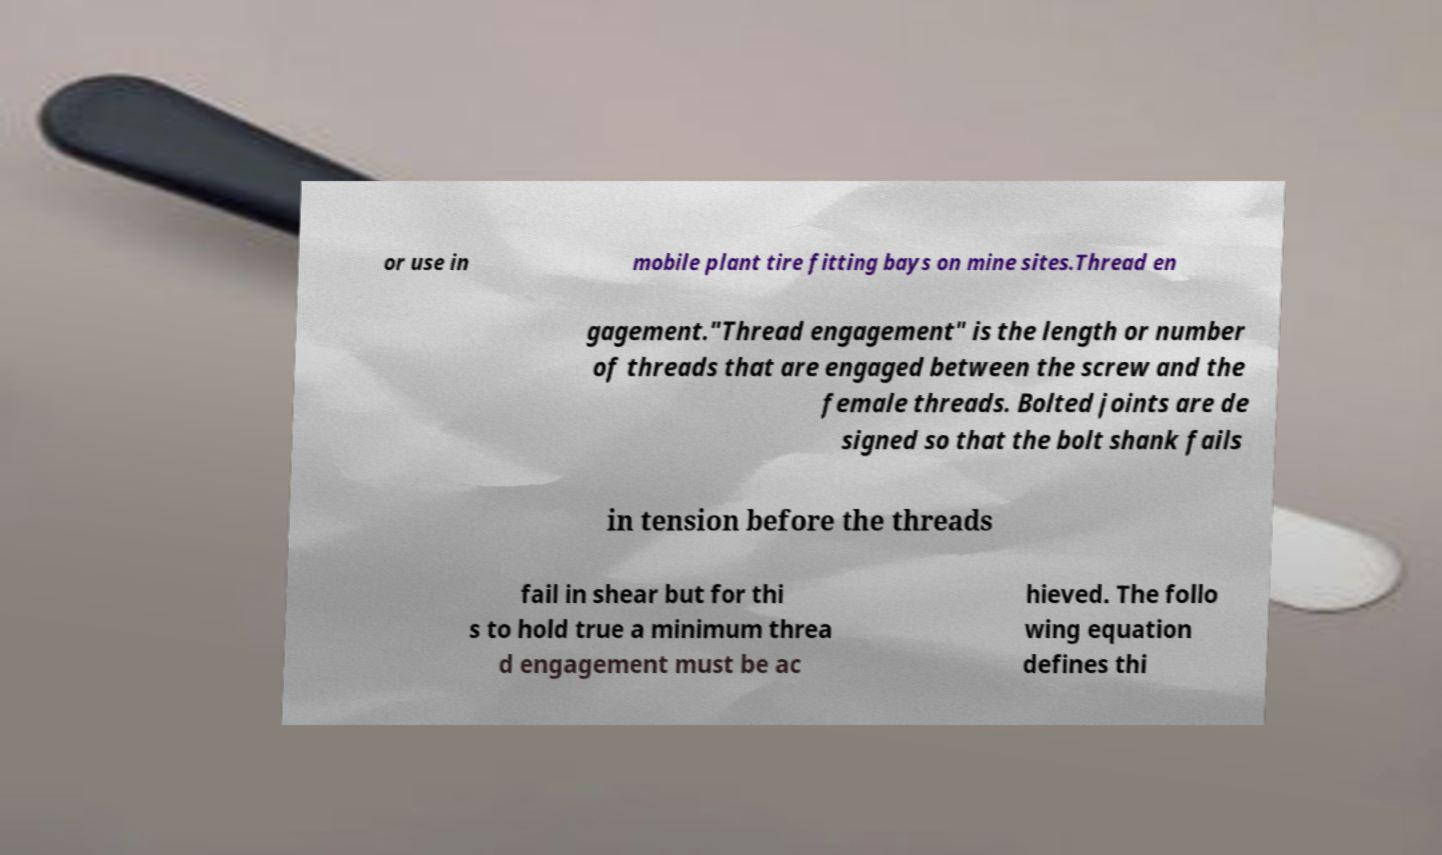Could you extract and type out the text from this image? or use in mobile plant tire fitting bays on mine sites.Thread en gagement."Thread engagement" is the length or number of threads that are engaged between the screw and the female threads. Bolted joints are de signed so that the bolt shank fails in tension before the threads fail in shear but for thi s to hold true a minimum threa d engagement must be ac hieved. The follo wing equation defines thi 